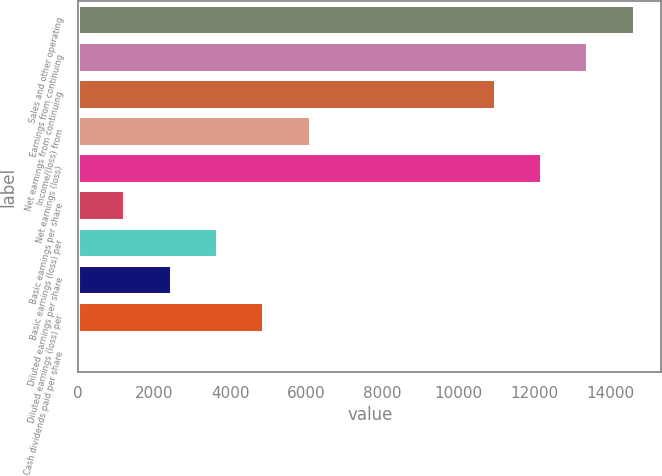<chart> <loc_0><loc_0><loc_500><loc_500><bar_chart><fcel>Sales and other operating<fcel>Earnings from continuing<fcel>Net earnings from continuing<fcel>Income/(loss) from<fcel>Net earnings (loss)<fcel>Basic earnings per share<fcel>Basic earnings (loss) per<fcel>Diluted earnings per share<fcel>Diluted earnings (loss) per<fcel>Cash dividends paid per share<nl><fcel>14620.7<fcel>13402.4<fcel>10965.6<fcel>6092.07<fcel>12184<fcel>1218.55<fcel>3655.31<fcel>2436.93<fcel>4873.69<fcel>0.17<nl></chart> 